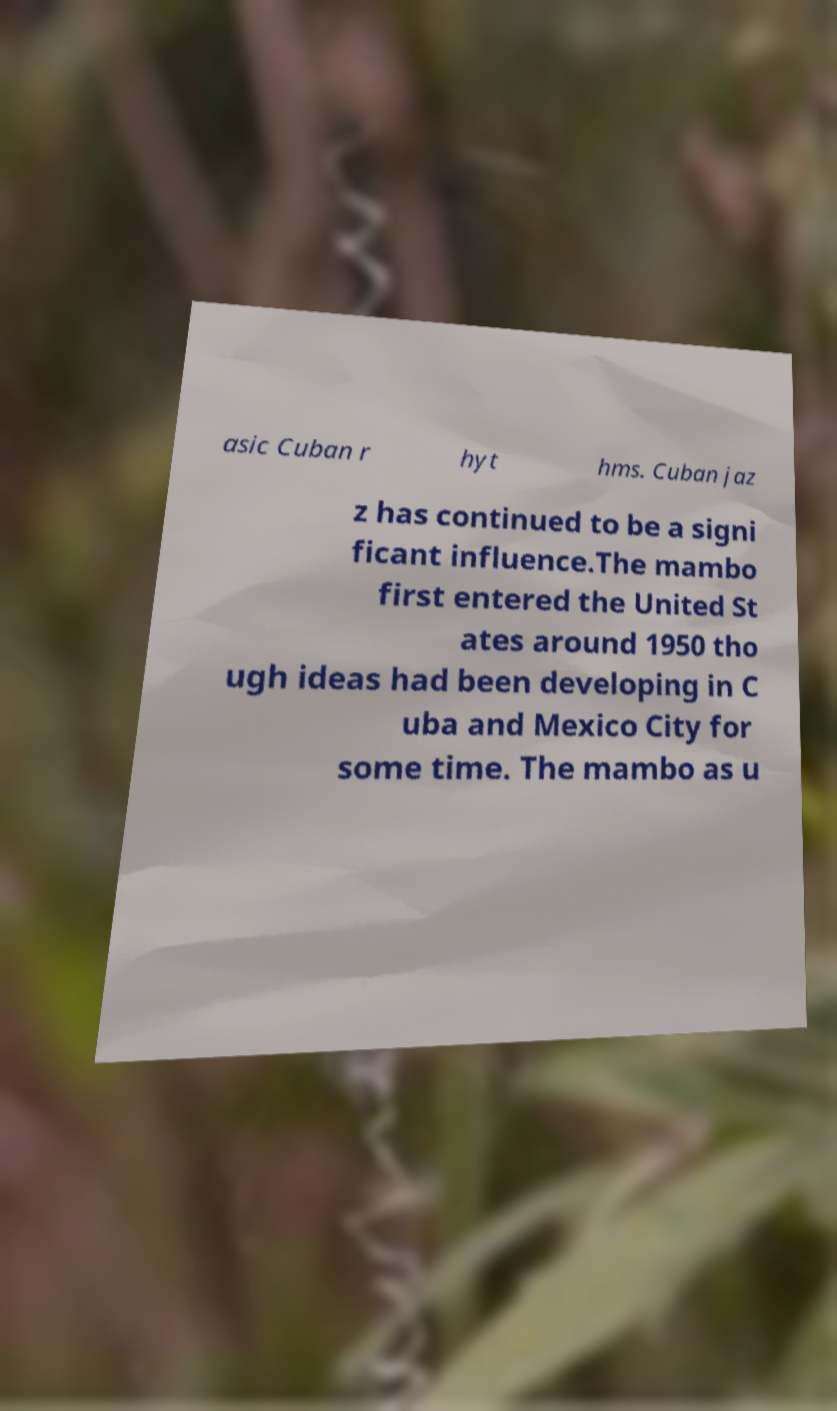What messages or text are displayed in this image? I need them in a readable, typed format. asic Cuban r hyt hms. Cuban jaz z has continued to be a signi ficant influence.The mambo first entered the United St ates around 1950 tho ugh ideas had been developing in C uba and Mexico City for some time. The mambo as u 